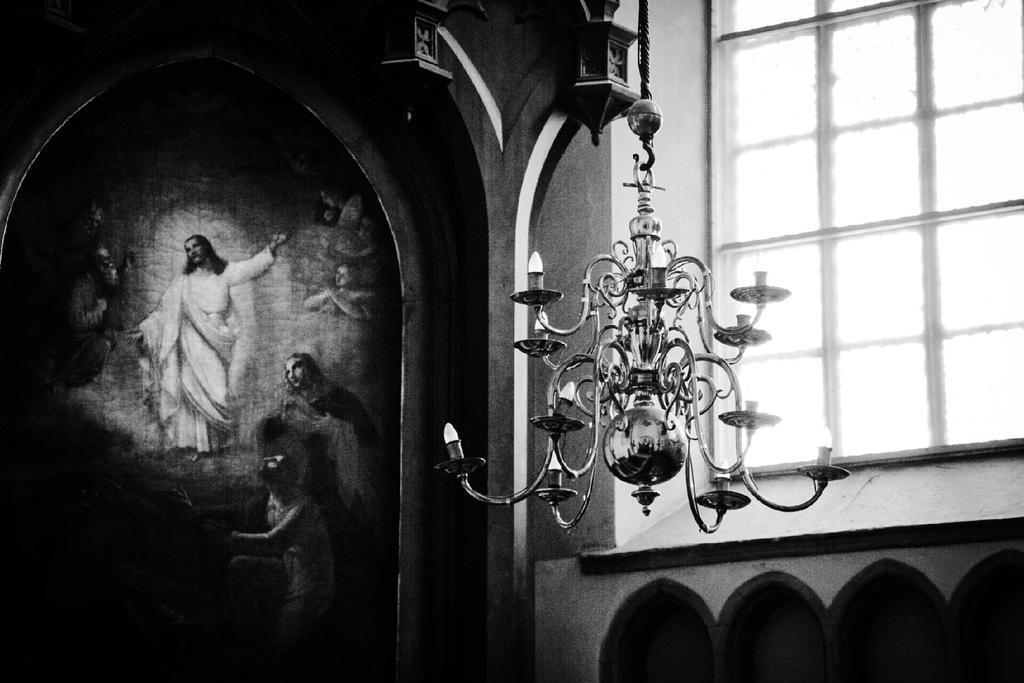Could you give a brief overview of what you see in this image? Here this picture is a black and white image, in which on the left side we can see pictures of Jesus and other people on the wall and in the middle we can see a chandelier hanging and on the right side we can see a window present on the building. 